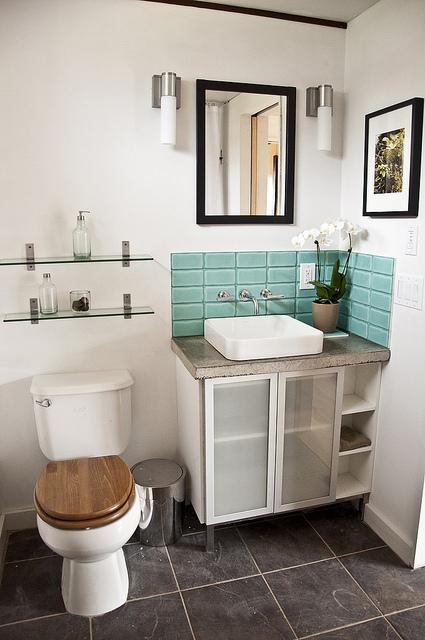What room of the house is this?
Give a very brief answer. Bathroom. Is the toilet lid down?
Give a very brief answer. Yes. How many decorations do you see?
Keep it brief. 2. What color is the tile around the sink?
Quick response, please. Turquoise. What is sitting on top of the mirror?
Quick response, please. Nothing. 